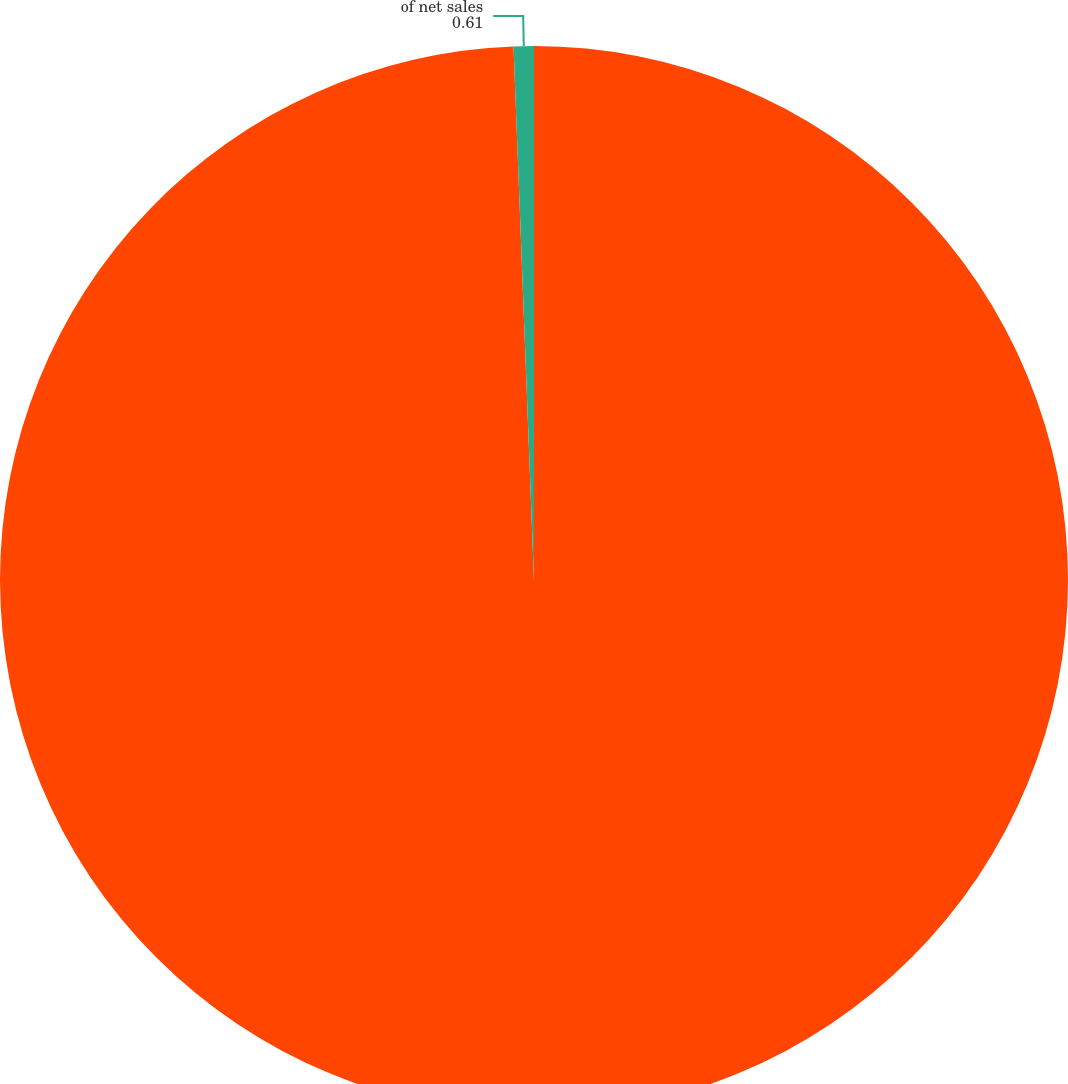Convert chart to OTSL. <chart><loc_0><loc_0><loc_500><loc_500><pie_chart><fcel>Net sales<fcel>of net sales<nl><fcel>99.39%<fcel>0.61%<nl></chart> 